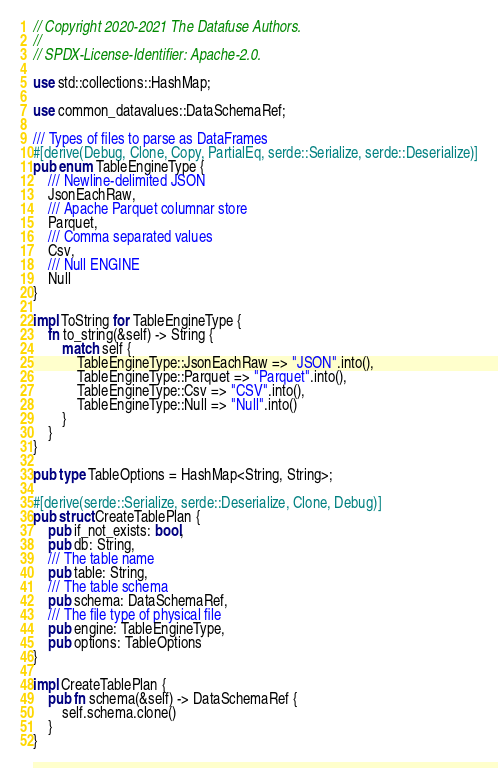<code> <loc_0><loc_0><loc_500><loc_500><_Rust_>// Copyright 2020-2021 The Datafuse Authors.
//
// SPDX-License-Identifier: Apache-2.0.

use std::collections::HashMap;

use common_datavalues::DataSchemaRef;

/// Types of files to parse as DataFrames
#[derive(Debug, Clone, Copy, PartialEq, serde::Serialize, serde::Deserialize)]
pub enum TableEngineType {
    /// Newline-delimited JSON
    JsonEachRaw,
    /// Apache Parquet columnar store
    Parquet,
    /// Comma separated values
    Csv,
    /// Null ENGINE
    Null
}

impl ToString for TableEngineType {
    fn to_string(&self) -> String {
        match self {
            TableEngineType::JsonEachRaw => "JSON".into(),
            TableEngineType::Parquet => "Parquet".into(),
            TableEngineType::Csv => "CSV".into(),
            TableEngineType::Null => "Null".into()
        }
    }
}

pub type TableOptions = HashMap<String, String>;

#[derive(serde::Serialize, serde::Deserialize, Clone, Debug)]
pub struct CreateTablePlan {
    pub if_not_exists: bool,
    pub db: String,
    /// The table name
    pub table: String,
    /// The table schema
    pub schema: DataSchemaRef,
    /// The file type of physical file
    pub engine: TableEngineType,
    pub options: TableOptions
}

impl CreateTablePlan {
    pub fn schema(&self) -> DataSchemaRef {
        self.schema.clone()
    }
}
</code> 